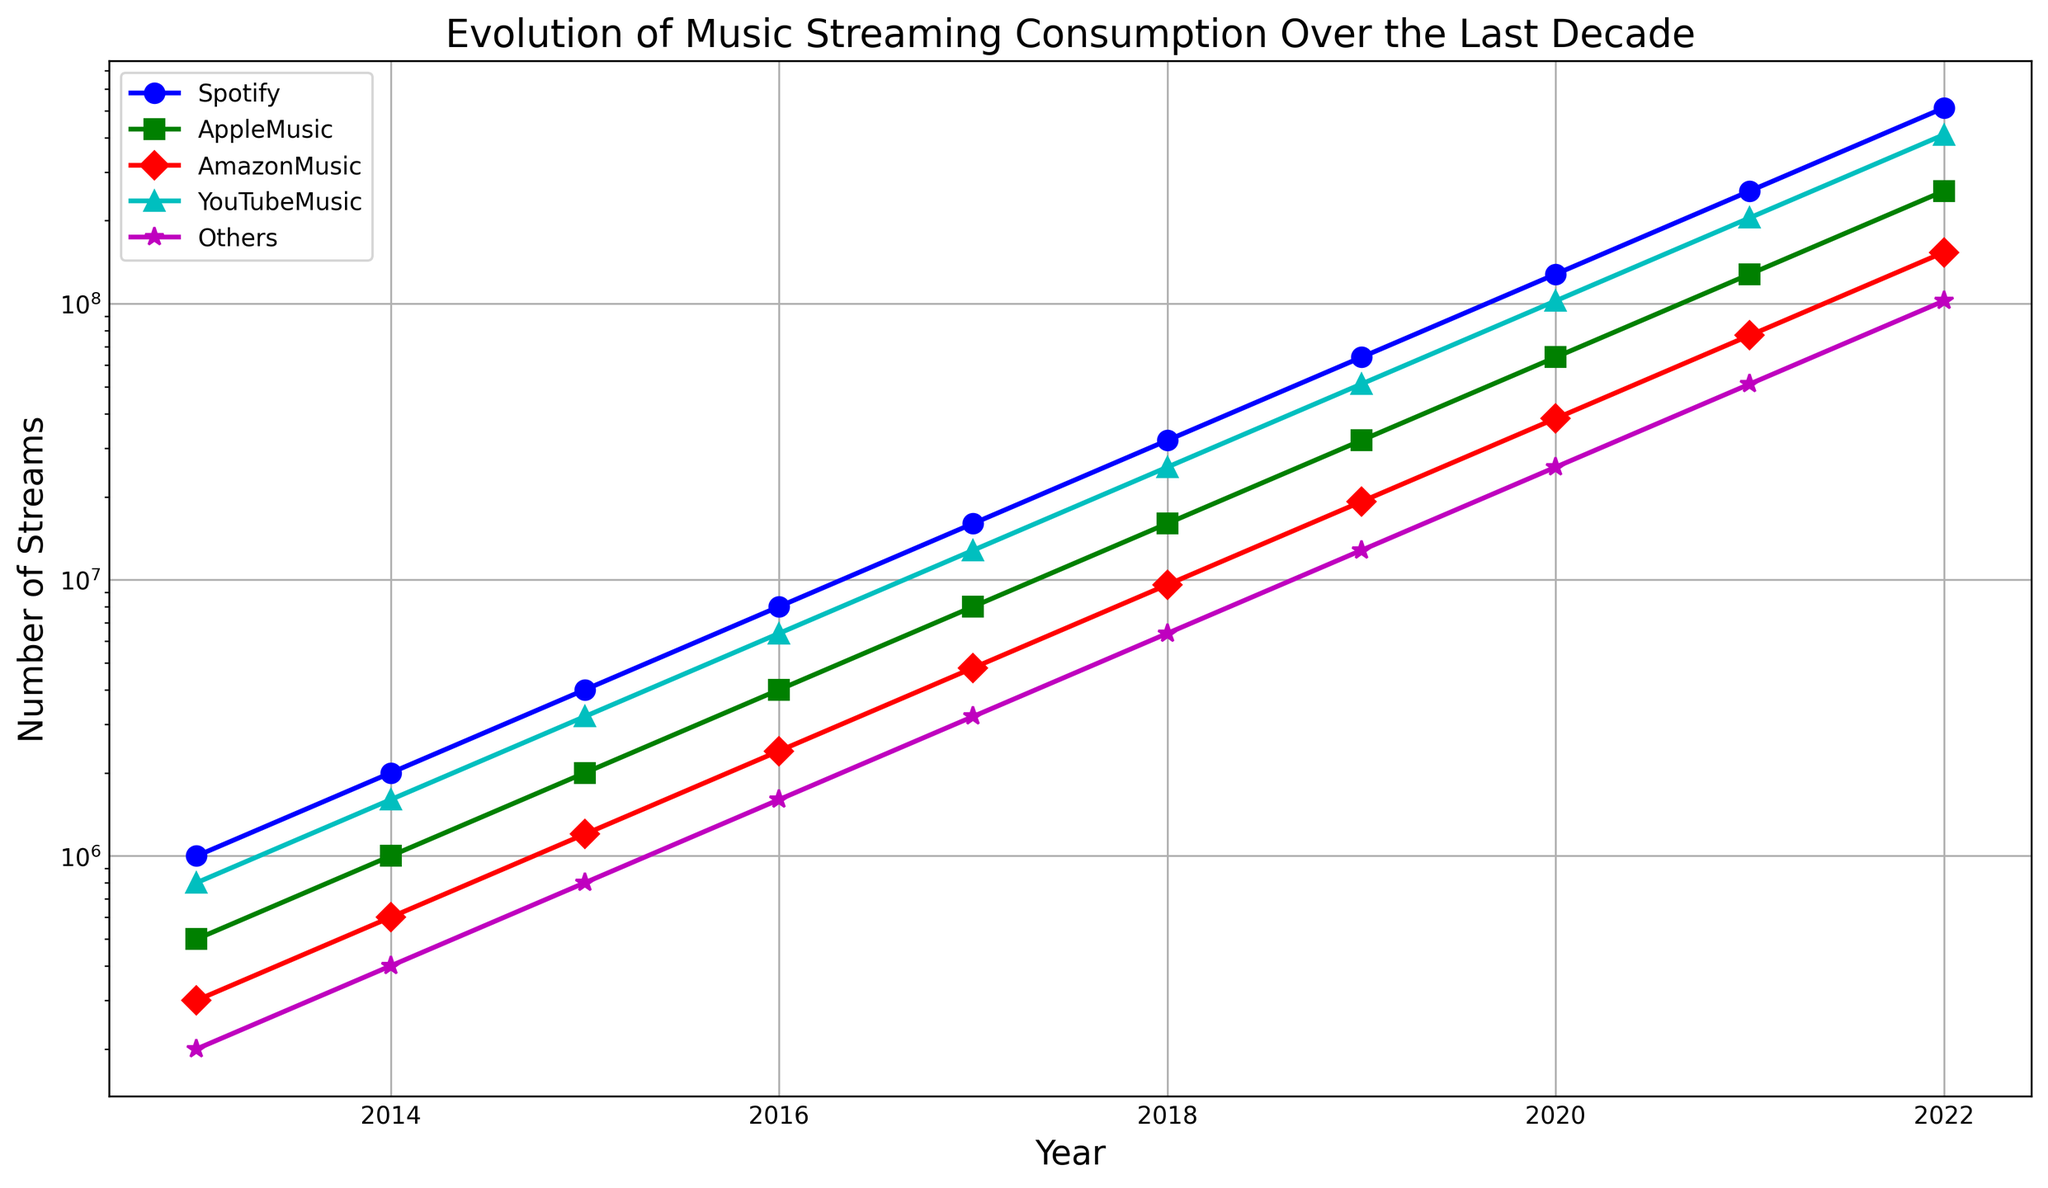Which platform saw the highest increase in the number of streams from 2013 to 2022? To determine this, subtract the number of streams in 2013 from the number of streams in 2022 for each platform. Spotify's increase is 512,000,000 - 1,000,000 = 511,000,000; Apple Music's increase is 256,000,000 - 500,000 = 255,500,000. Amazon Music's increase is 153,600,000 - 300,000 = 153,300,000. YouTube Music's increase is 409,600,000 - 800,000 = 408,800,000. Others saw an increase of 102,400,000 - 200,000 = 102,200,000. Thus, Spotify saw the highest increase.
Answer: Spotify In which year did YouTube Music first surpass 100 million streams? Look at the year-wise data for YouTube Music and find the first year where the number of streams exceeds 100 million. This happens in 2019, with 102,400,000 streams.
Answer: 2019 How does the number of streams for Amazon Music in 2021 compare to Apple Music in 2018? Amazon Music in 2021 has 76,800,000 streams, whereas Apple Music in 2018 has 16,000,000 streams. The number of streams for Amazon Music in 2021 is higher.
Answer: Amazon Music has more What's the total number of streams in 2020 across all platforms? Sum the number of streams in 2020 for all platforms: 128,000,000 (Spotify) + 64,000,000 (Apple Music) + 38,400,000 (Amazon Music) + 102,400,000 (YouTube Music) + 25,600,000 (Others) = 358,400,000.
Answer: 358,400,000 Which platform had the smallest increase in the number of streams between 2013 and 2016? Calculate the increase for each platform between 2013 and 2016: Spotify: 8,000,000 - 1,000,000 = 7,000,000; Apple Music: 4,000,000 - 500,000 = 3,500,000; Amazon Music: 2,400,000 - 300,000 = 2,100,000; YouTube Music: 6,400,000 - 800,000 = 5,600,000; Others: 1,600,000 - 200,000 = 1,400,000. The smallest increase is for "Others" with 1,400,000.
Answer: Others How did the total number of streams change from 2015 to 2017? First, sum the total number of streams for each year: 2015: 4,000,000 (Spotify) + 2,000,000 (Apple Music) + 1,200,000 (Amazon Music) + 3,200,000 (YouTube Music) + 800,000 (Others) = 11,200,000. 2017: 16,000,000 (Spotify) + 8,000,000 (Apple Music) + 4,800,000 (Amazon Music) + 12,800,000 (YouTube Music) + 3,200,000 (Others) = 44,800,000. The change from 2015 to 2017 is 44,800,000 - 11,200,000 = 33,600,000.
Answer: 33,600,000 Is the number of streams for Apple Music in 2022 more than ten times its number in 2014? Apple Music had 1,000,000 streams in 2014 and 256,000,000 streams in 2022. Ten times its 2014 number is 10,000,000. Since 256,000,000 is greater than 10,000,000, the answer is yes.
Answer: Yes What is the percentage increase in YouTube Music streams from 2016 to 2018? Find the increase from 2016 to 2018 (25,600,000 - 6,400,000 = 19,200,000). The percentage increase is (19,200,000 / 6,400,000) * 100 = 300%.
Answer: 300% Which year shows the biggest relative increase in Spotify streams compared to the previous year? Calculate the relative increase for each year as a ratio (current year streams / previous year streams): 
    - 2014/2013: 2,000,000 / 1,000,000 = 2 (100% increase)
    - 2015/2014: 4,000,000 / 2,000,000 = 2 (100% increase)
    - 2016/2015: 8,000,000 / 4,000,000 = 2 (100% increase)
    - 2017/2016: 16,000,000 / 8,000,000 = 2 (100% increase)
    - 2018/2017: 32,000,000 / 16,000,000 = 2 (100% increase)
    - 2019/2018: 64,000,000 / 32,000,000 = 2 (100% increase)
    - 2020/2019: 128,000,000 / 64,000,000 = 2 (100% increase)
    - 2021/2020: 256,000,000 / 128,000,000 = 2 (100% increase)
    - 2022/2021: 512,000,000 / 256,000,000 = 2 (100% increase)
Each year shows the same relative increase of 100%.
Answer: 2014 to 2022 